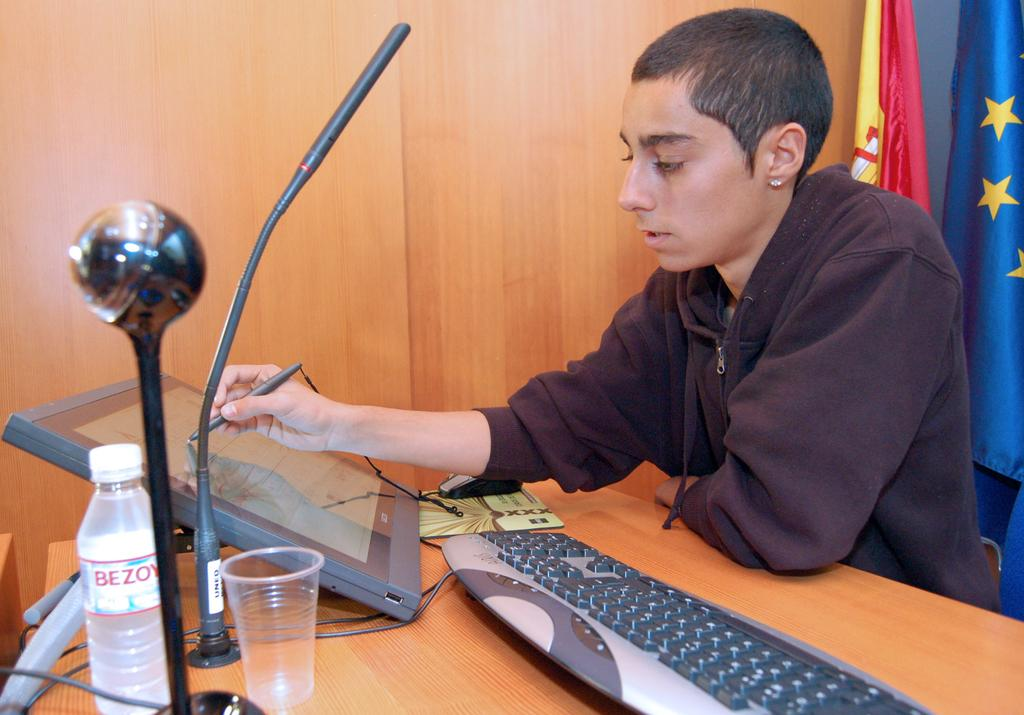What is the person in the image doing? The person is sitting in the image and holding a pen. What objects are related to the person's activity in the image? There is a screen, a keyboard, and a mouse in the image, which suggests that the person is using a computer. What other items can be seen in the image? There is a book, a glass, and a bottle in the image. What is the background of the image like? There is a wooden wall in the background, and there are flags visible as well. Are there any cables in the image? Yes, there are cables in the image. How does the person in the image participate in the committee meeting? There is no indication in the image that the person is participating in a committee meeting, nor is there any reference to a committee in the provided facts. 